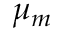Convert formula to latex. <formula><loc_0><loc_0><loc_500><loc_500>\mu _ { m } \,</formula> 